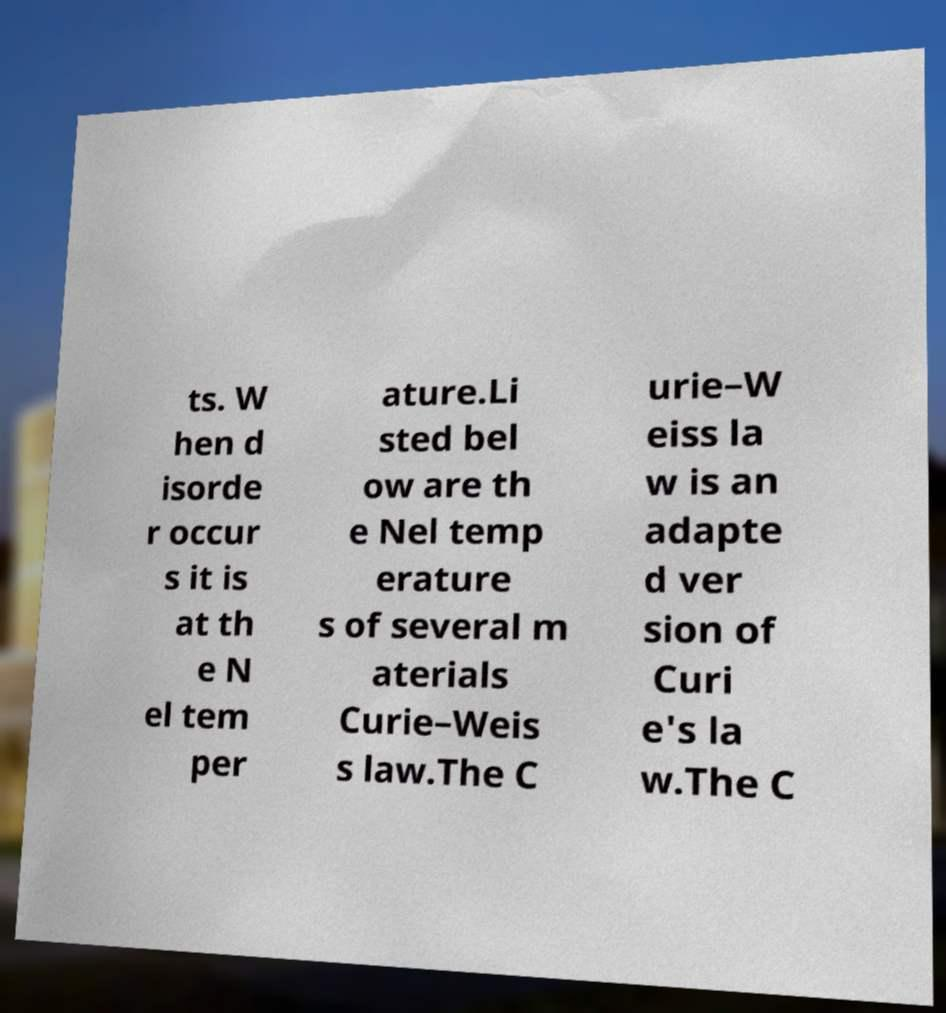I need the written content from this picture converted into text. Can you do that? ts. W hen d isorde r occur s it is at th e N el tem per ature.Li sted bel ow are th e Nel temp erature s of several m aterials Curie–Weis s law.The C urie–W eiss la w is an adapte d ver sion of Curi e's la w.The C 